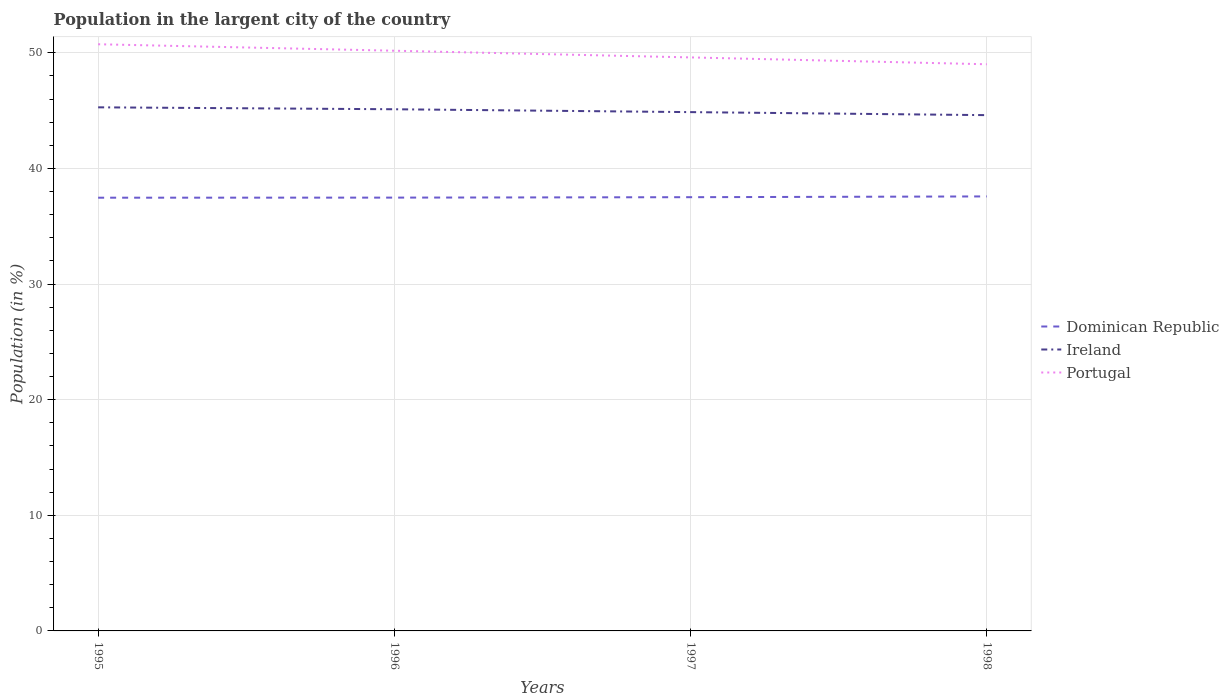Across all years, what is the maximum percentage of population in the largent city in Dominican Republic?
Offer a very short reply. 37.47. What is the total percentage of population in the largent city in Ireland in the graph?
Provide a short and direct response. 0.25. What is the difference between the highest and the second highest percentage of population in the largent city in Portugal?
Provide a succinct answer. 1.73. How many years are there in the graph?
Your response must be concise. 4. Are the values on the major ticks of Y-axis written in scientific E-notation?
Ensure brevity in your answer.  No. Does the graph contain grids?
Provide a succinct answer. Yes. How are the legend labels stacked?
Your answer should be very brief. Vertical. What is the title of the graph?
Your response must be concise. Population in the largent city of the country. What is the label or title of the X-axis?
Provide a short and direct response. Years. What is the Population (in %) of Dominican Republic in 1995?
Make the answer very short. 37.47. What is the Population (in %) in Ireland in 1995?
Provide a short and direct response. 45.28. What is the Population (in %) in Portugal in 1995?
Provide a short and direct response. 50.74. What is the Population (in %) in Dominican Republic in 1996?
Keep it short and to the point. 37.47. What is the Population (in %) of Ireland in 1996?
Your answer should be compact. 45.11. What is the Population (in %) in Portugal in 1996?
Your answer should be very brief. 50.18. What is the Population (in %) of Dominican Republic in 1997?
Give a very brief answer. 37.51. What is the Population (in %) in Ireland in 1997?
Your response must be concise. 44.87. What is the Population (in %) in Portugal in 1997?
Offer a terse response. 49.6. What is the Population (in %) in Dominican Republic in 1998?
Ensure brevity in your answer.  37.58. What is the Population (in %) of Ireland in 1998?
Your response must be concise. 44.6. What is the Population (in %) of Portugal in 1998?
Provide a short and direct response. 49.01. Across all years, what is the maximum Population (in %) in Dominican Republic?
Provide a short and direct response. 37.58. Across all years, what is the maximum Population (in %) in Ireland?
Ensure brevity in your answer.  45.28. Across all years, what is the maximum Population (in %) of Portugal?
Your response must be concise. 50.74. Across all years, what is the minimum Population (in %) of Dominican Republic?
Provide a short and direct response. 37.47. Across all years, what is the minimum Population (in %) of Ireland?
Give a very brief answer. 44.6. Across all years, what is the minimum Population (in %) in Portugal?
Your answer should be very brief. 49.01. What is the total Population (in %) in Dominican Republic in the graph?
Offer a very short reply. 150.02. What is the total Population (in %) in Ireland in the graph?
Give a very brief answer. 179.87. What is the total Population (in %) of Portugal in the graph?
Give a very brief answer. 199.52. What is the difference between the Population (in %) in Dominican Republic in 1995 and that in 1996?
Your answer should be compact. -0.01. What is the difference between the Population (in %) in Ireland in 1995 and that in 1996?
Offer a very short reply. 0.17. What is the difference between the Population (in %) of Portugal in 1995 and that in 1996?
Your response must be concise. 0.56. What is the difference between the Population (in %) of Dominican Republic in 1995 and that in 1997?
Keep it short and to the point. -0.04. What is the difference between the Population (in %) in Ireland in 1995 and that in 1997?
Offer a terse response. 0.41. What is the difference between the Population (in %) of Portugal in 1995 and that in 1997?
Offer a very short reply. 1.14. What is the difference between the Population (in %) in Dominican Republic in 1995 and that in 1998?
Your response must be concise. -0.11. What is the difference between the Population (in %) of Ireland in 1995 and that in 1998?
Your answer should be compact. 0.68. What is the difference between the Population (in %) in Portugal in 1995 and that in 1998?
Keep it short and to the point. 1.73. What is the difference between the Population (in %) in Dominican Republic in 1996 and that in 1997?
Your answer should be compact. -0.04. What is the difference between the Population (in %) of Ireland in 1996 and that in 1997?
Your answer should be very brief. 0.25. What is the difference between the Population (in %) of Portugal in 1996 and that in 1997?
Your response must be concise. 0.58. What is the difference between the Population (in %) in Dominican Republic in 1996 and that in 1998?
Keep it short and to the point. -0.1. What is the difference between the Population (in %) of Ireland in 1996 and that in 1998?
Provide a succinct answer. 0.51. What is the difference between the Population (in %) in Portugal in 1996 and that in 1998?
Your answer should be very brief. 1.17. What is the difference between the Population (in %) of Dominican Republic in 1997 and that in 1998?
Give a very brief answer. -0.07. What is the difference between the Population (in %) in Ireland in 1997 and that in 1998?
Your answer should be very brief. 0.26. What is the difference between the Population (in %) in Portugal in 1997 and that in 1998?
Provide a succinct answer. 0.59. What is the difference between the Population (in %) of Dominican Republic in 1995 and the Population (in %) of Ireland in 1996?
Offer a very short reply. -7.65. What is the difference between the Population (in %) in Dominican Republic in 1995 and the Population (in %) in Portugal in 1996?
Your answer should be very brief. -12.71. What is the difference between the Population (in %) in Ireland in 1995 and the Population (in %) in Portugal in 1996?
Ensure brevity in your answer.  -4.89. What is the difference between the Population (in %) of Dominican Republic in 1995 and the Population (in %) of Ireland in 1997?
Provide a short and direct response. -7.4. What is the difference between the Population (in %) in Dominican Republic in 1995 and the Population (in %) in Portugal in 1997?
Make the answer very short. -12.13. What is the difference between the Population (in %) in Ireland in 1995 and the Population (in %) in Portugal in 1997?
Your answer should be compact. -4.32. What is the difference between the Population (in %) in Dominican Republic in 1995 and the Population (in %) in Ireland in 1998?
Provide a short and direct response. -7.14. What is the difference between the Population (in %) in Dominican Republic in 1995 and the Population (in %) in Portugal in 1998?
Ensure brevity in your answer.  -11.54. What is the difference between the Population (in %) of Ireland in 1995 and the Population (in %) of Portugal in 1998?
Make the answer very short. -3.72. What is the difference between the Population (in %) in Dominican Republic in 1996 and the Population (in %) in Ireland in 1997?
Offer a terse response. -7.39. What is the difference between the Population (in %) in Dominican Republic in 1996 and the Population (in %) in Portugal in 1997?
Give a very brief answer. -12.12. What is the difference between the Population (in %) in Ireland in 1996 and the Population (in %) in Portugal in 1997?
Provide a short and direct response. -4.48. What is the difference between the Population (in %) of Dominican Republic in 1996 and the Population (in %) of Ireland in 1998?
Give a very brief answer. -7.13. What is the difference between the Population (in %) of Dominican Republic in 1996 and the Population (in %) of Portugal in 1998?
Your answer should be compact. -11.53. What is the difference between the Population (in %) of Ireland in 1996 and the Population (in %) of Portugal in 1998?
Offer a very short reply. -3.89. What is the difference between the Population (in %) in Dominican Republic in 1997 and the Population (in %) in Ireland in 1998?
Provide a succinct answer. -7.1. What is the difference between the Population (in %) of Dominican Republic in 1997 and the Population (in %) of Portugal in 1998?
Your answer should be very brief. -11.5. What is the difference between the Population (in %) in Ireland in 1997 and the Population (in %) in Portugal in 1998?
Provide a succinct answer. -4.14. What is the average Population (in %) in Dominican Republic per year?
Your response must be concise. 37.51. What is the average Population (in %) of Ireland per year?
Provide a succinct answer. 44.97. What is the average Population (in %) in Portugal per year?
Your answer should be very brief. 49.88. In the year 1995, what is the difference between the Population (in %) of Dominican Republic and Population (in %) of Ireland?
Give a very brief answer. -7.82. In the year 1995, what is the difference between the Population (in %) of Dominican Republic and Population (in %) of Portugal?
Ensure brevity in your answer.  -13.27. In the year 1995, what is the difference between the Population (in %) of Ireland and Population (in %) of Portugal?
Provide a succinct answer. -5.45. In the year 1996, what is the difference between the Population (in %) of Dominican Republic and Population (in %) of Ireland?
Your answer should be compact. -7.64. In the year 1996, what is the difference between the Population (in %) in Dominican Republic and Population (in %) in Portugal?
Provide a short and direct response. -12.7. In the year 1996, what is the difference between the Population (in %) of Ireland and Population (in %) of Portugal?
Your answer should be very brief. -5.06. In the year 1997, what is the difference between the Population (in %) of Dominican Republic and Population (in %) of Ireland?
Ensure brevity in your answer.  -7.36. In the year 1997, what is the difference between the Population (in %) of Dominican Republic and Population (in %) of Portugal?
Give a very brief answer. -12.09. In the year 1997, what is the difference between the Population (in %) of Ireland and Population (in %) of Portugal?
Your answer should be very brief. -4.73. In the year 1998, what is the difference between the Population (in %) in Dominican Republic and Population (in %) in Ireland?
Keep it short and to the point. -7.03. In the year 1998, what is the difference between the Population (in %) of Dominican Republic and Population (in %) of Portugal?
Your answer should be compact. -11.43. In the year 1998, what is the difference between the Population (in %) in Ireland and Population (in %) in Portugal?
Provide a succinct answer. -4.4. What is the ratio of the Population (in %) in Dominican Republic in 1995 to that in 1996?
Make the answer very short. 1. What is the ratio of the Population (in %) of Ireland in 1995 to that in 1996?
Ensure brevity in your answer.  1. What is the ratio of the Population (in %) of Portugal in 1995 to that in 1996?
Provide a succinct answer. 1.01. What is the ratio of the Population (in %) of Dominican Republic in 1995 to that in 1997?
Ensure brevity in your answer.  1. What is the ratio of the Population (in %) of Ireland in 1995 to that in 1997?
Ensure brevity in your answer.  1.01. What is the ratio of the Population (in %) of Portugal in 1995 to that in 1997?
Make the answer very short. 1.02. What is the ratio of the Population (in %) in Ireland in 1995 to that in 1998?
Provide a succinct answer. 1.02. What is the ratio of the Population (in %) in Portugal in 1995 to that in 1998?
Make the answer very short. 1.04. What is the ratio of the Population (in %) of Dominican Republic in 1996 to that in 1997?
Provide a succinct answer. 1. What is the ratio of the Population (in %) of Portugal in 1996 to that in 1997?
Your answer should be very brief. 1.01. What is the ratio of the Population (in %) of Ireland in 1996 to that in 1998?
Make the answer very short. 1.01. What is the ratio of the Population (in %) of Portugal in 1996 to that in 1998?
Keep it short and to the point. 1.02. What is the ratio of the Population (in %) of Dominican Republic in 1997 to that in 1998?
Ensure brevity in your answer.  1. What is the ratio of the Population (in %) in Ireland in 1997 to that in 1998?
Offer a terse response. 1.01. What is the ratio of the Population (in %) in Portugal in 1997 to that in 1998?
Your answer should be very brief. 1.01. What is the difference between the highest and the second highest Population (in %) in Dominican Republic?
Ensure brevity in your answer.  0.07. What is the difference between the highest and the second highest Population (in %) in Ireland?
Your answer should be compact. 0.17. What is the difference between the highest and the second highest Population (in %) in Portugal?
Your response must be concise. 0.56. What is the difference between the highest and the lowest Population (in %) in Dominican Republic?
Your response must be concise. 0.11. What is the difference between the highest and the lowest Population (in %) of Ireland?
Offer a terse response. 0.68. What is the difference between the highest and the lowest Population (in %) of Portugal?
Make the answer very short. 1.73. 